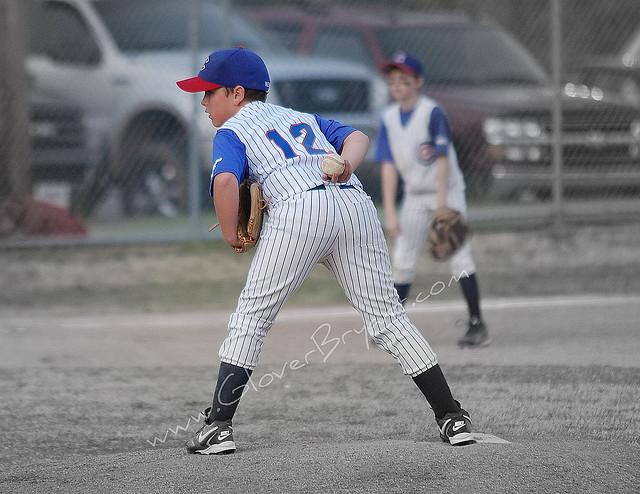What position is the boy with the ball playing?
Concise answer only. Pitcher. What is the boy holding in his right hand?
Answer briefly. Baseball. What number is on the boy's uniform?
Write a very short answer. 12. What number is on his shirt?
Be succinct. 12. 